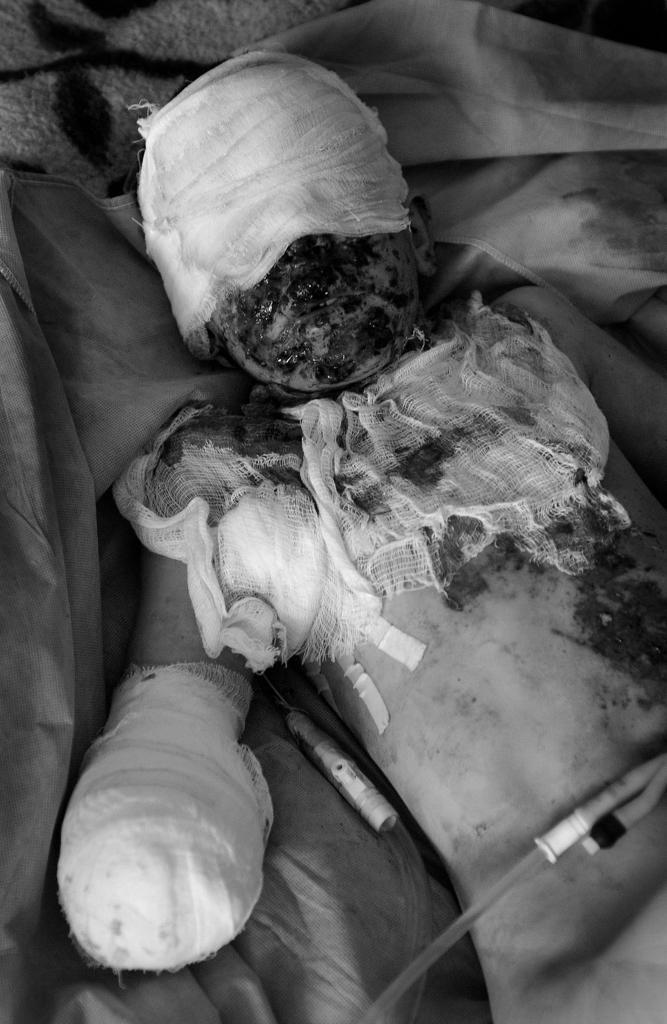Could you give a brief overview of what you see in this image? In this picture I can see a person who is lying and I see the bandages on the head, hand and on the chest and it looks like blood on the face and on the body. On the bottom of this picture I can see 2 pipes and I see that this person is lying on the clothes. 